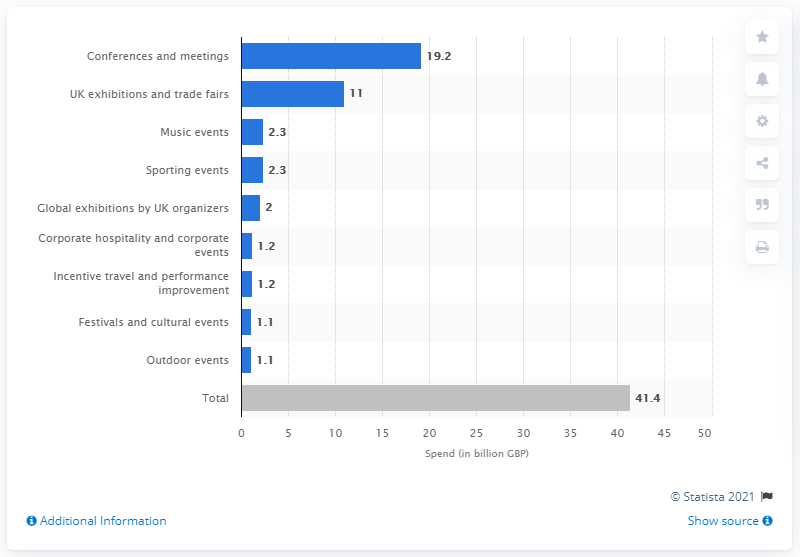How many British pounds were spent on conferences and meetings in 2017? In 2017, a total of 19.2 billion British pounds were spent on conferences and meetings, as depicted in the bar chart. 